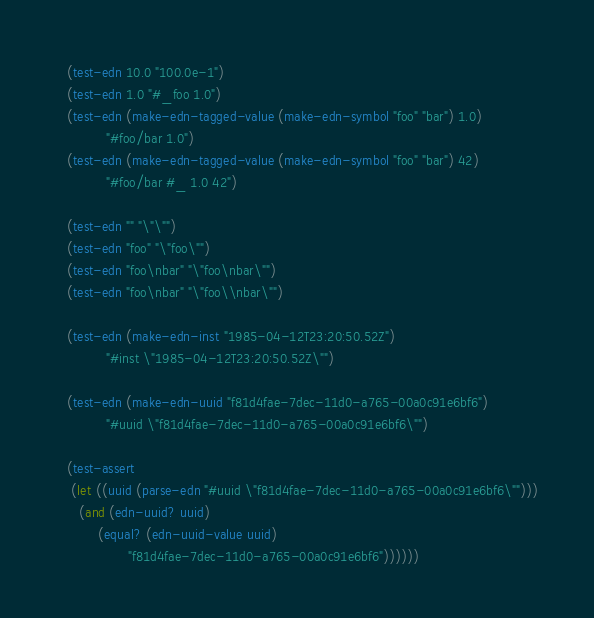Convert code to text. <code><loc_0><loc_0><loc_500><loc_500><_Scheme_>   (test-edn 10.0 "100.0e-1")
   (test-edn 1.0 "#_foo 1.0")
   (test-edn (make-edn-tagged-value (make-edn-symbol "foo" "bar") 1.0)
             "#foo/bar 1.0")
   (test-edn (make-edn-tagged-value (make-edn-symbol "foo" "bar") 42)
             "#foo/bar #_ 1.0 42")

   (test-edn "" "\"\"")
   (test-edn "foo" "\"foo\"")
   (test-edn "foo\nbar" "\"foo\nbar\"")
   (test-edn "foo\nbar" "\"foo\\nbar\"")

   (test-edn (make-edn-inst "1985-04-12T23:20:50.52Z")
             "#inst \"1985-04-12T23:20:50.52Z\"")

   (test-edn (make-edn-uuid "f81d4fae-7dec-11d0-a765-00a0c91e6bf6")
             "#uuid \"f81d4fae-7dec-11d0-a765-00a0c91e6bf6\"")

   (test-assert
    (let ((uuid (parse-edn "#uuid \"f81d4fae-7dec-11d0-a765-00a0c91e6bf6\"")))
      (and (edn-uuid? uuid)
           (equal? (edn-uuid-value uuid)
                   "f81d4fae-7dec-11d0-a765-00a0c91e6bf6"))))))
</code> 